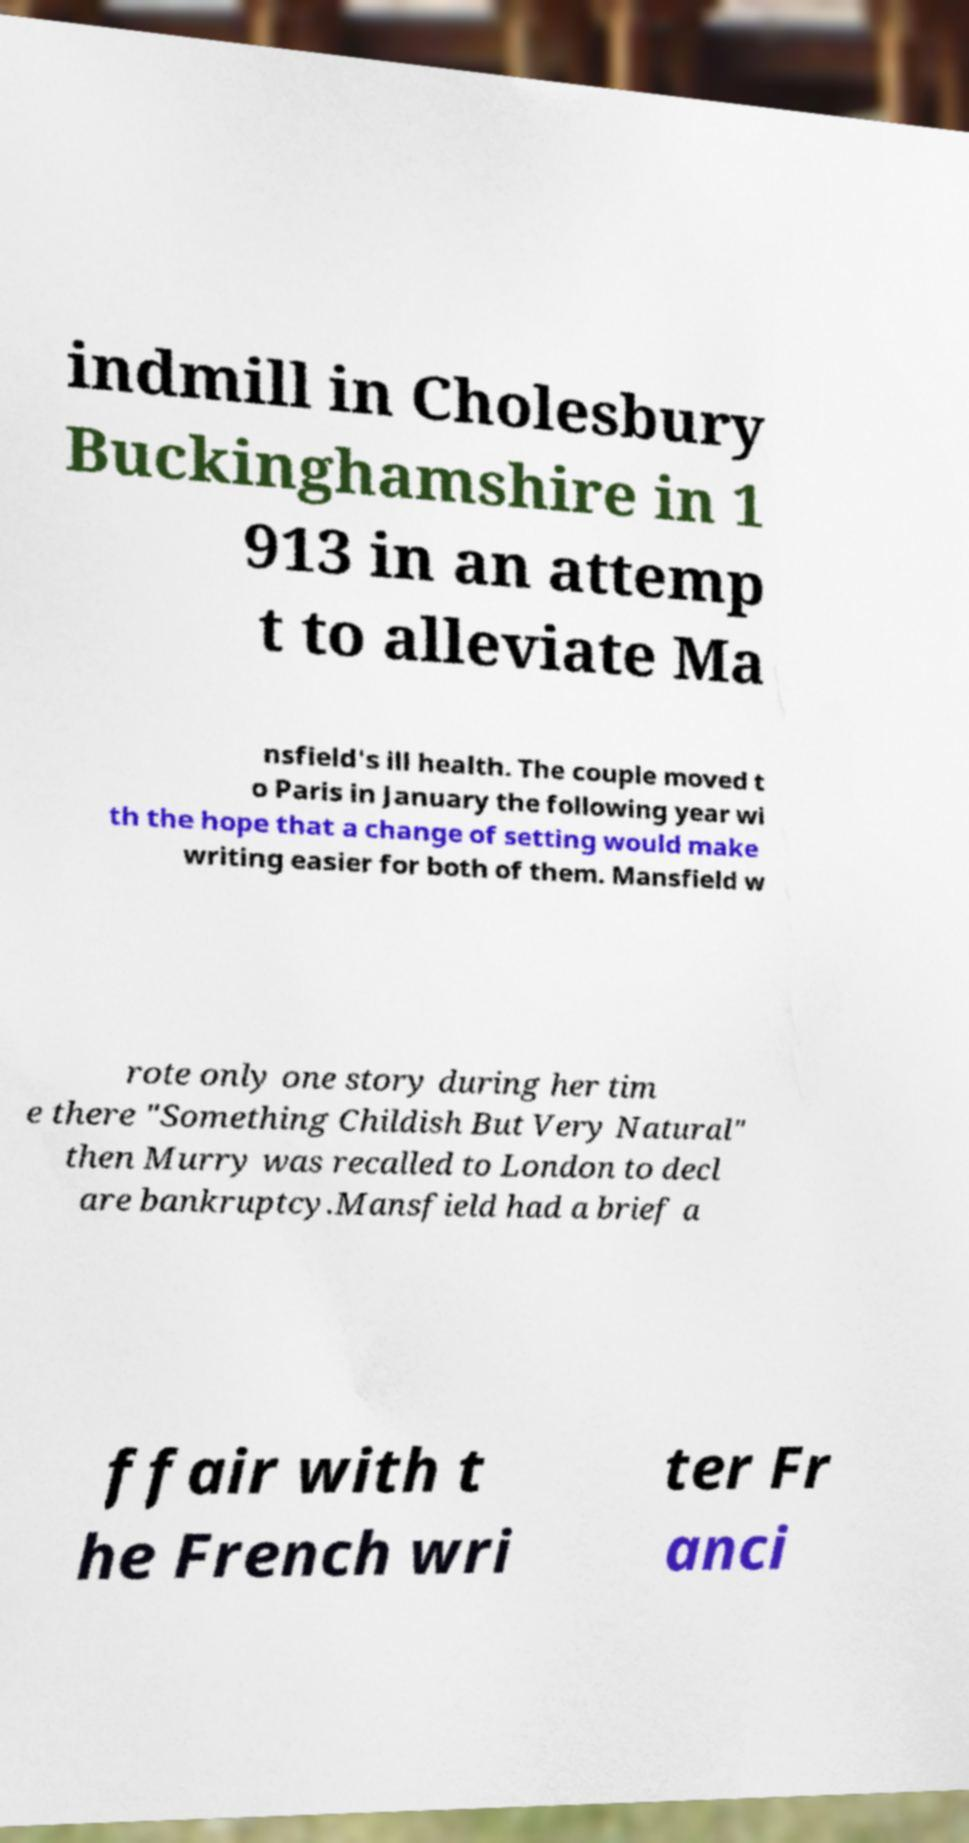For documentation purposes, I need the text within this image transcribed. Could you provide that? indmill in Cholesbury Buckinghamshire in 1 913 in an attemp t to alleviate Ma nsfield's ill health. The couple moved t o Paris in January the following year wi th the hope that a change of setting would make writing easier for both of them. Mansfield w rote only one story during her tim e there "Something Childish But Very Natural" then Murry was recalled to London to decl are bankruptcy.Mansfield had a brief a ffair with t he French wri ter Fr anci 